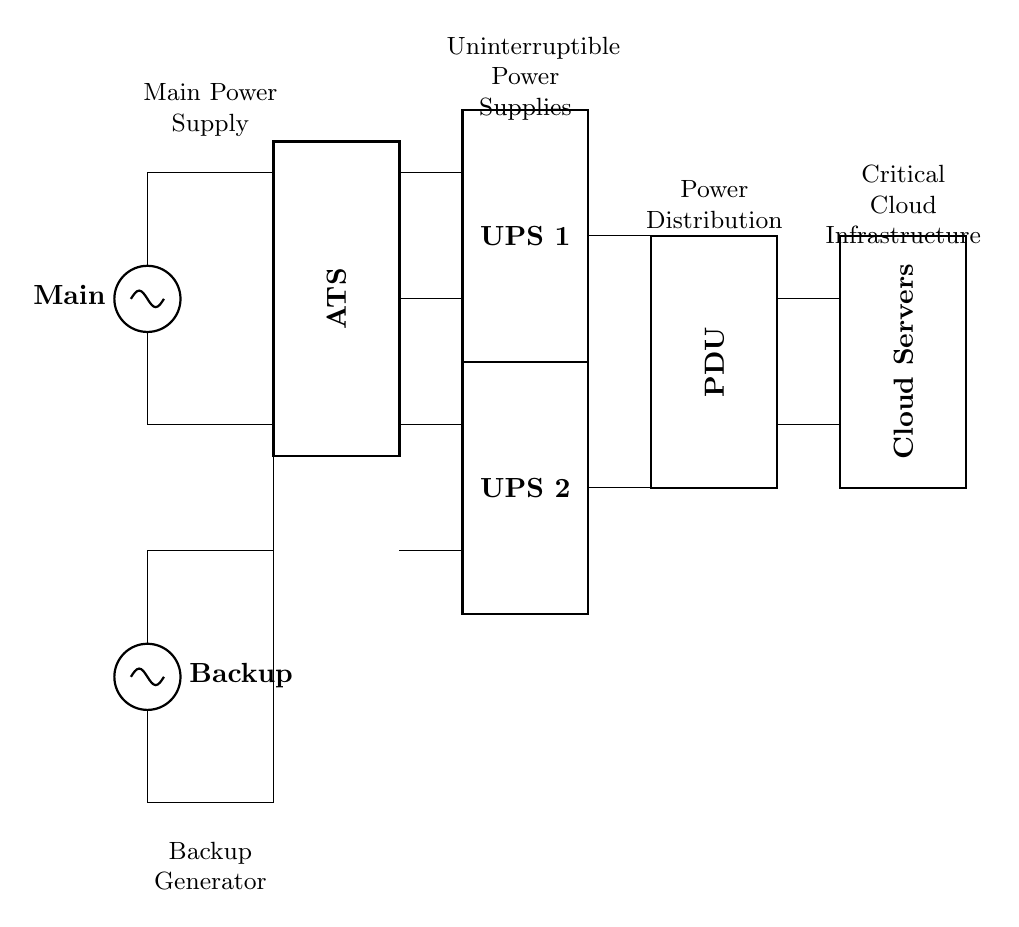What are the two main types of power supply? The circuit diagram shows a main power supply and a backup generator, indicating the two main types of power sources.
Answer: Main power supply, backup generator What components are connected to the Automatic Transfer Switch? The Automatic Transfer Switch is connected to the main power supply above and the backup generator below, allowing it to manage power sources effectively.
Answer: Main power supply, backup generator How many Uninterruptible Power Supplies are present? There are two Uninterruptible Power Supplies (UPS 1 and UPS 2) indicated in the circuit diagram.
Answer: Two What is the purpose of the Power Distribution Unit? The Power Distribution Unit distributes power to other components, specifically the critical cloud infrastructure, ensuring reliable power delivery.
Answer: Distributes power What happens to the cloud servers during a power outage? In case of a power outage, the backup generator will provide power through the Automatic Transfer Switch, and the Uninterruptible Power Supplies will maintain power to the cloud servers to prevent downtime.
Answer: They remain powered What role does UPS 1 play in redundancy? UPS 1 acts as one component in a redundant system that ensures continuous power supply to the cloud servers even if one source fails.
Answer: Continuous power supply What is the significance of having two UPS systems? Having two UPS systems allows for redundancy; if one fails, the other can continue to provide power, maintaining operation during outages.
Answer: Redundancy 